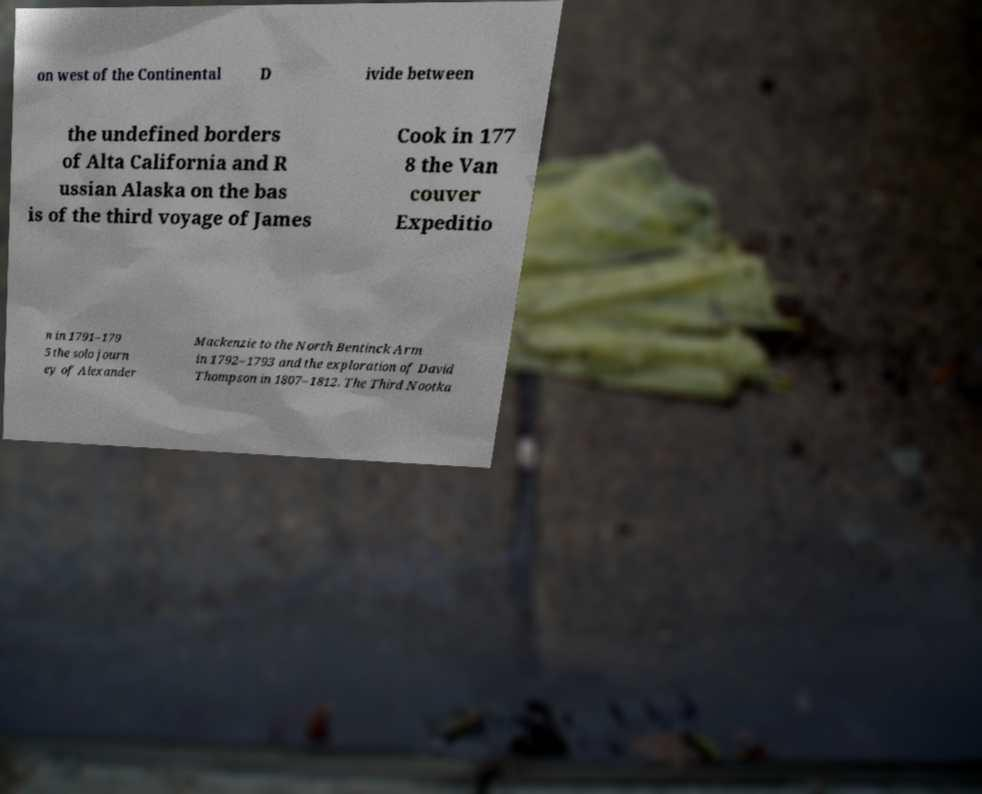Please identify and transcribe the text found in this image. on west of the Continental D ivide between the undefined borders of Alta California and R ussian Alaska on the bas is of the third voyage of James Cook in 177 8 the Van couver Expeditio n in 1791–179 5 the solo journ ey of Alexander Mackenzie to the North Bentinck Arm in 1792–1793 and the exploration of David Thompson in 1807–1812. The Third Nootka 